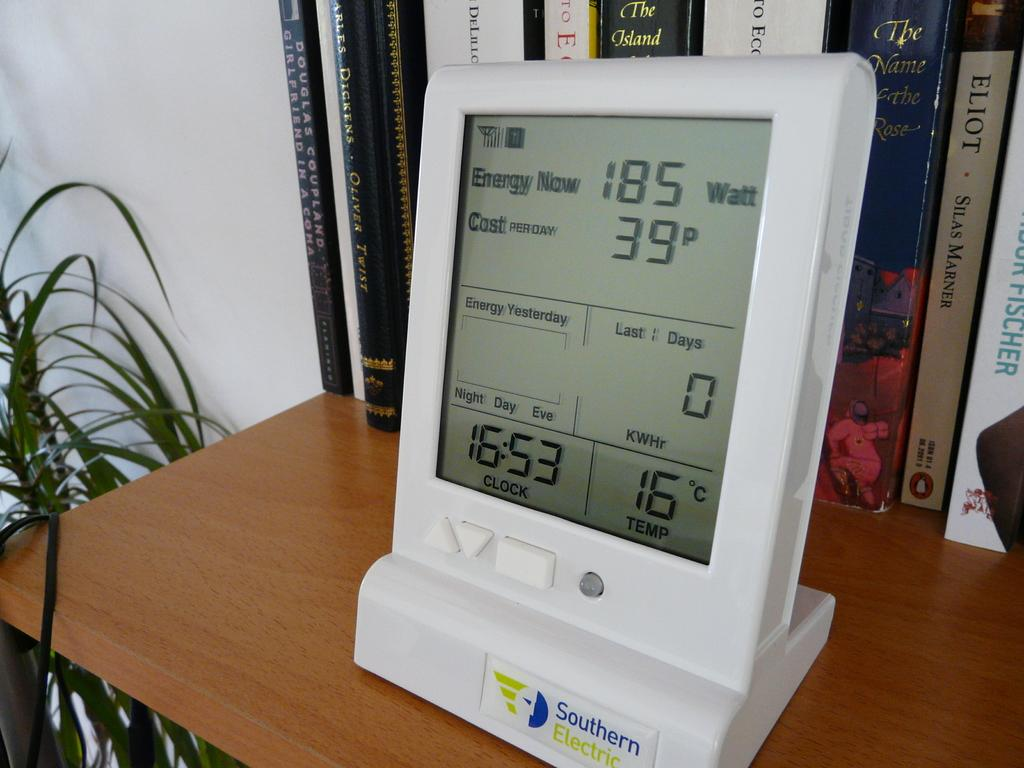<image>
Provide a brief description of the given image. Screen that says the time on it is 16:53. 